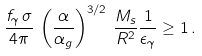<formula> <loc_0><loc_0><loc_500><loc_500>\frac { f _ { \gamma } \, \sigma } { 4 \pi } \, \left ( \frac { \alpha } { \alpha _ { g } } \right ) ^ { 3 / 2 } \, \frac { M _ { s } } { R ^ { 2 } } \frac { 1 } { \epsilon _ { \gamma } } \geq 1 \, .</formula> 